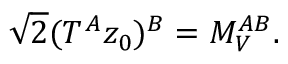Convert formula to latex. <formula><loc_0><loc_0><loc_500><loc_500>\sqrt { 2 } ( T ^ { A } z _ { 0 } ) ^ { B } = M _ { V } ^ { A B } .</formula> 